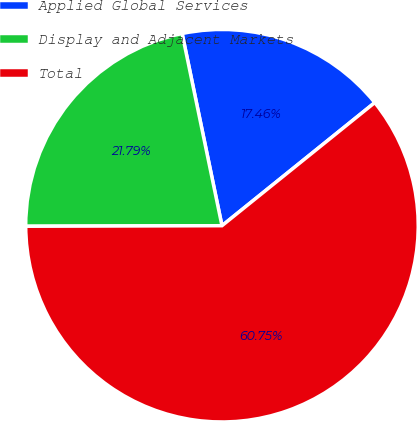Convert chart. <chart><loc_0><loc_0><loc_500><loc_500><pie_chart><fcel>Applied Global Services<fcel>Display and Adjacent Markets<fcel>Total<nl><fcel>17.46%<fcel>21.79%<fcel>60.75%<nl></chart> 